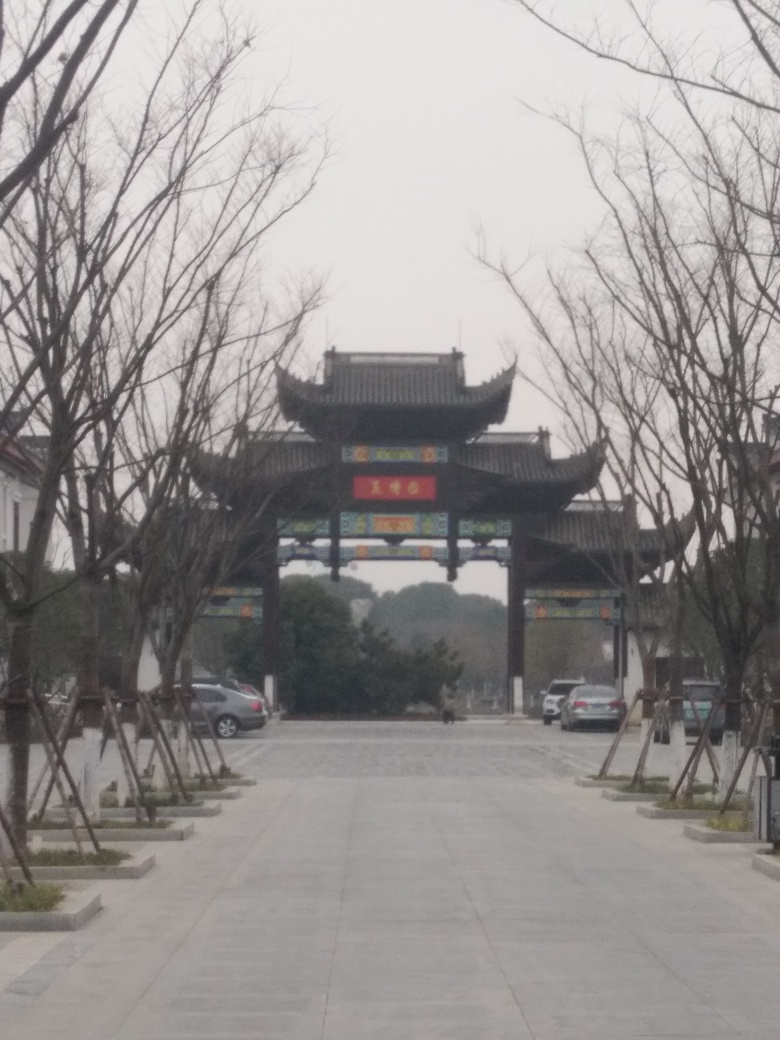What might this place be used for? Given the grandeur and traditional design of the gate, this place could be a cultural heritage site, such as a historic district, temple complex, or a garden entrance. It serves both a decorative and functional role, marking the entrance to the area and evoking a sense of grandiosity and reverence associated with the location's significance. 